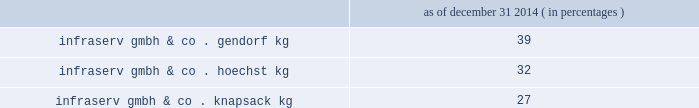Fortron industries llc .
Fortron is a leading global producer of pps , sold under the fortron ae brand , which is used in a wide variety of automotive and other applications , especially those requiring heat and/or chemical resistance .
Fortron's facility is located in wilmington , north carolina .
This venture combines the sales , marketing , distribution , compounding and manufacturing expertise of celanese with the pps polymer technology expertise of kureha america inc .
Cellulose derivatives strategic ventures .
Our cellulose derivatives ventures generally fund their operations using operating cash flow and pay dividends based on each ventures' performance in the preceding year .
In 2014 , 2013 and 2012 , we received cash dividends of $ 115 million , $ 92 million and $ 83 million , respectively .
Although our ownership interest in each of our cellulose derivatives ventures exceeds 20% ( 20 % ) , we account for these investments using the cost method of accounting because we determined that we cannot exercise significant influence over these entities due to local government investment in and influence over these entities , limitations on our involvement in the day-to-day operations and the present inability of the entities to provide timely financial information prepared in accordance with generally accepted accounting principles in the united states of america ( "us gaap" ) .
2022 other equity method investments infraservs .
We hold indirect ownership interests in several german infraserv groups that own and develop industrial parks and provide on-site general and administrative support to tenants .
Our ownership interest in the equity investments in infraserv affiliates are as follows : as of december 31 , 2014 ( in percentages ) .
Research and development our businesses are innovation-oriented and conduct research and development activities to develop new , and optimize existing , production technologies , as well as to develop commercially viable new products and applications .
Research and development expense was $ 86 million , $ 85 million and $ 104 million for the years ended december 31 , 2014 , 2013 and 2012 , respectively .
We consider the amounts spent during each of the last three fiscal years on research and development activities to be sufficient to execute our current strategic initiatives .
Intellectual property we attach importance to protecting our intellectual property , including safeguarding our confidential information and through our patents , trademarks and copyrights , in order to preserve our investment in research and development , manufacturing and marketing .
Patents may cover processes , equipment , products , intermediate products and product uses .
We also seek to register trademarks as a means of protecting the brand names of our company and products .
Patents .
In most industrial countries , patent protection exists for new substances and formulations , as well as for certain unique applications and production processes .
However , we do business in regions of the world where intellectual property protection may be limited and difficult to enforce .
Confidential information .
We maintain stringent information security policies and procedures wherever we do business .
Such information security policies and procedures include data encryption , controls over the disclosure and safekeeping of confidential information and trade secrets , as well as employee awareness training .
Trademarks .
Aoplus ae , aoplus ae2 , aoplus ae3 , ateva ae , avicor ae , britecoat ae , celanese ae , celanex ae , celcon ae , celfx 2122 , celstran ae , celvolit ae , clarifoil ae , duroset ae , ecovae ae , factor ae , fortron ae , gur ae , hostaform ae , impet ae , mowilith ae , nutrinova ae , qorus 2122 , riteflex ae , sunett ae , tcx 2122 , thermx ae , tufcor ae , vantage ae , vantageplus 2122 , vantage ae2 , vectra ae , vinamul ae , vitaldose ae , zenite ae and certain other branded products and services named in this document are registered or reserved trademarks or service marks owned or licensed by celanese .
The foregoing is not intended to be an exhaustive or comprehensive list of all registered or reserved trademarks and service marks owned or licensed by celanese .
Fortron ae is a registered trademark of fortron industries llc. .
What is the growth rate in research and development expenses from 2013 to 2014? 
Computations: ((86 - 85) / 85)
Answer: 0.01176. 